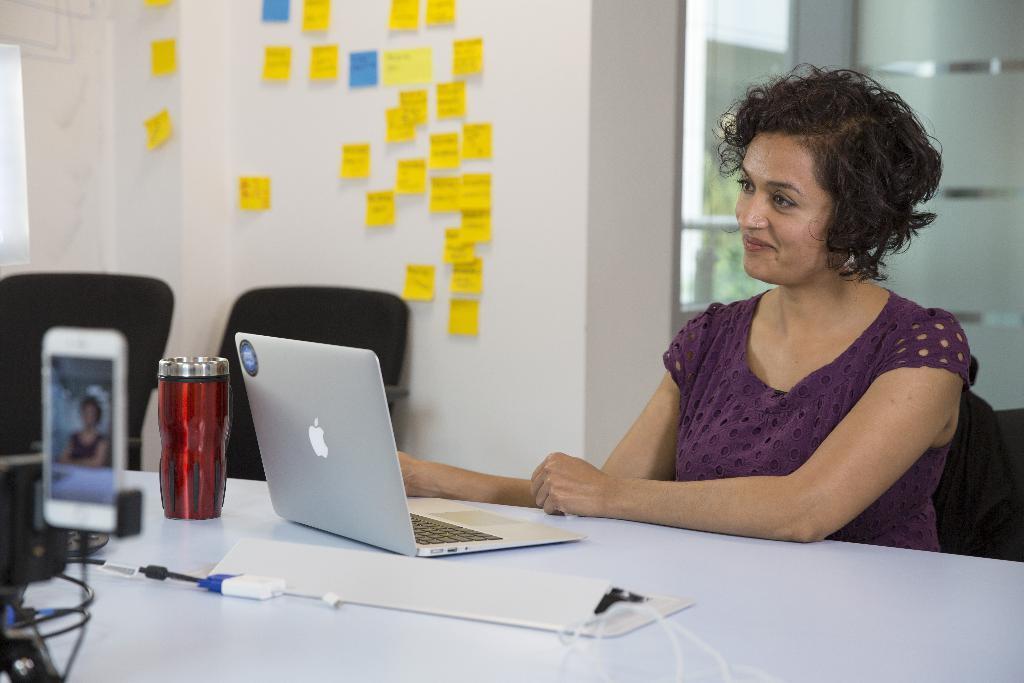Please provide a concise description of this image. In this picture there is a lady who is sitting at the right side of the image and there is a table in front of her, there is a window at the right side of the image. 